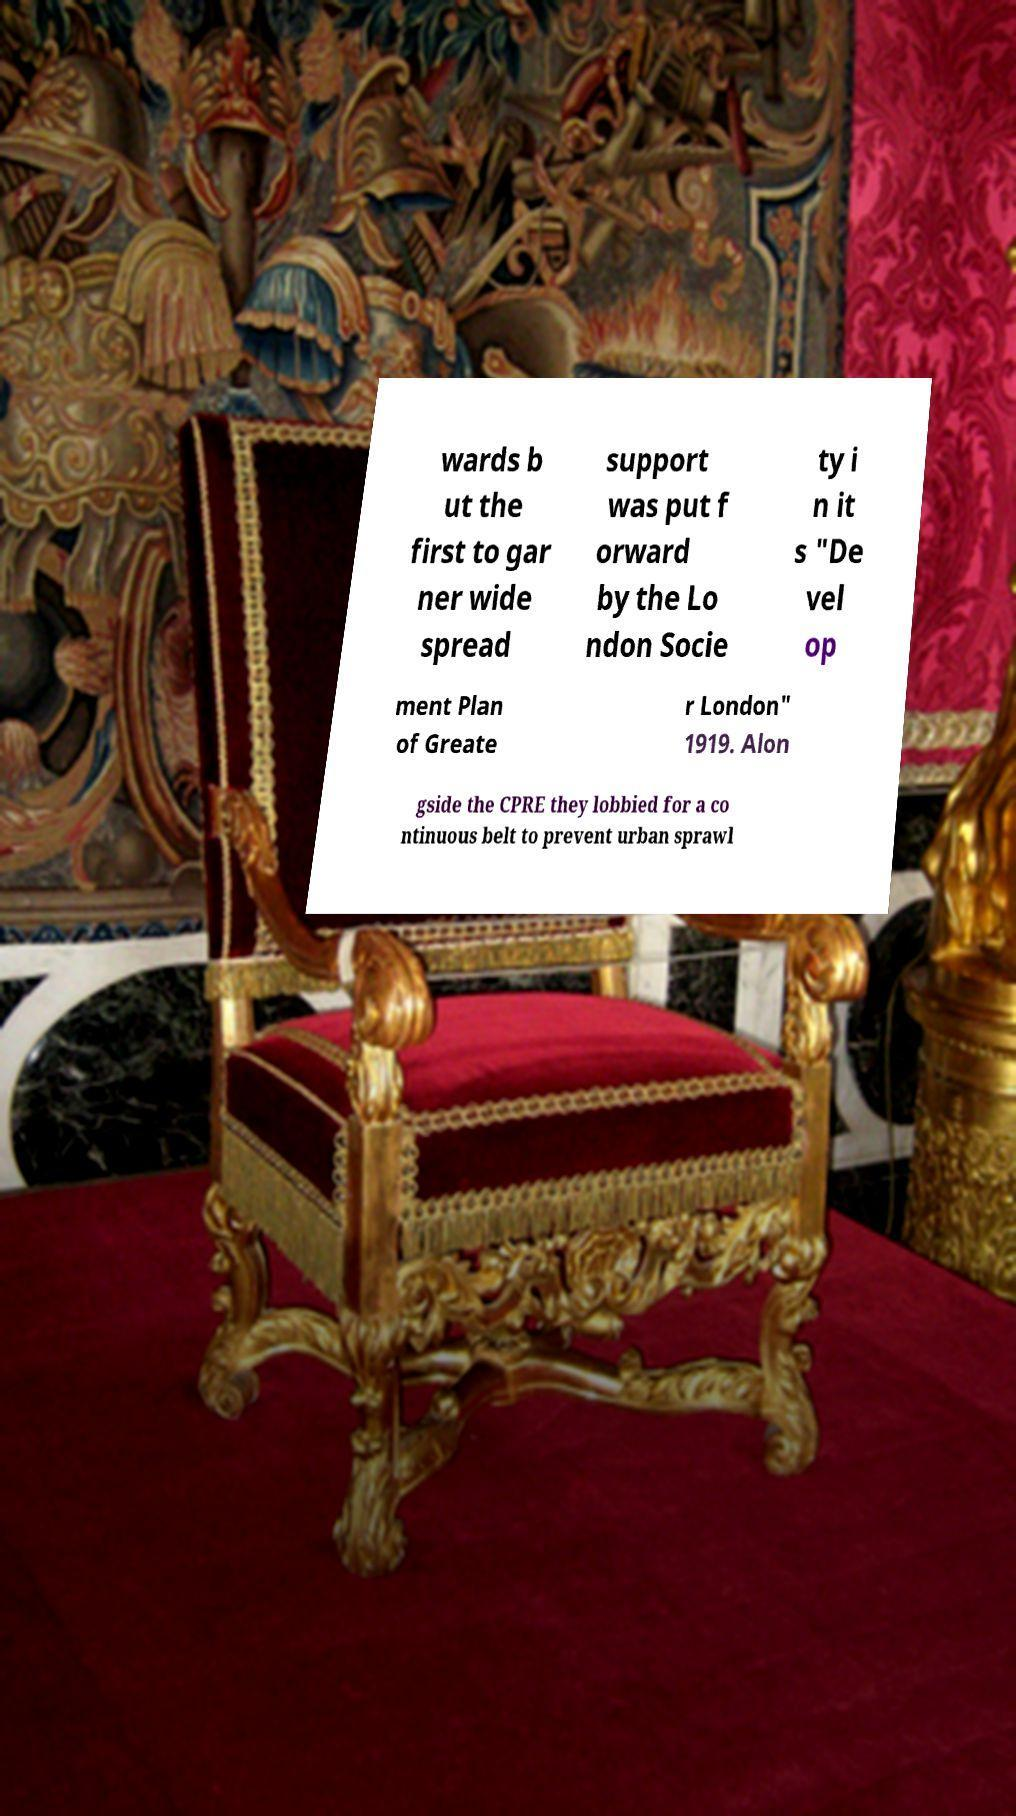I need the written content from this picture converted into text. Can you do that? wards b ut the first to gar ner wide spread support was put f orward by the Lo ndon Socie ty i n it s "De vel op ment Plan of Greate r London" 1919. Alon gside the CPRE they lobbied for a co ntinuous belt to prevent urban sprawl 